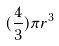Convert formula to latex. <formula><loc_0><loc_0><loc_500><loc_500>( \frac { 4 } { 3 } ) \pi r ^ { 3 }</formula> 